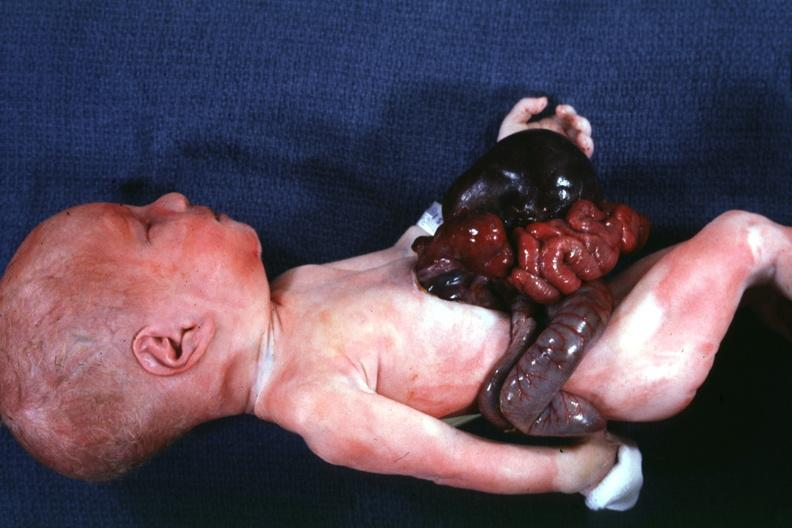s abdomen present?
Answer the question using a single word or phrase. No 